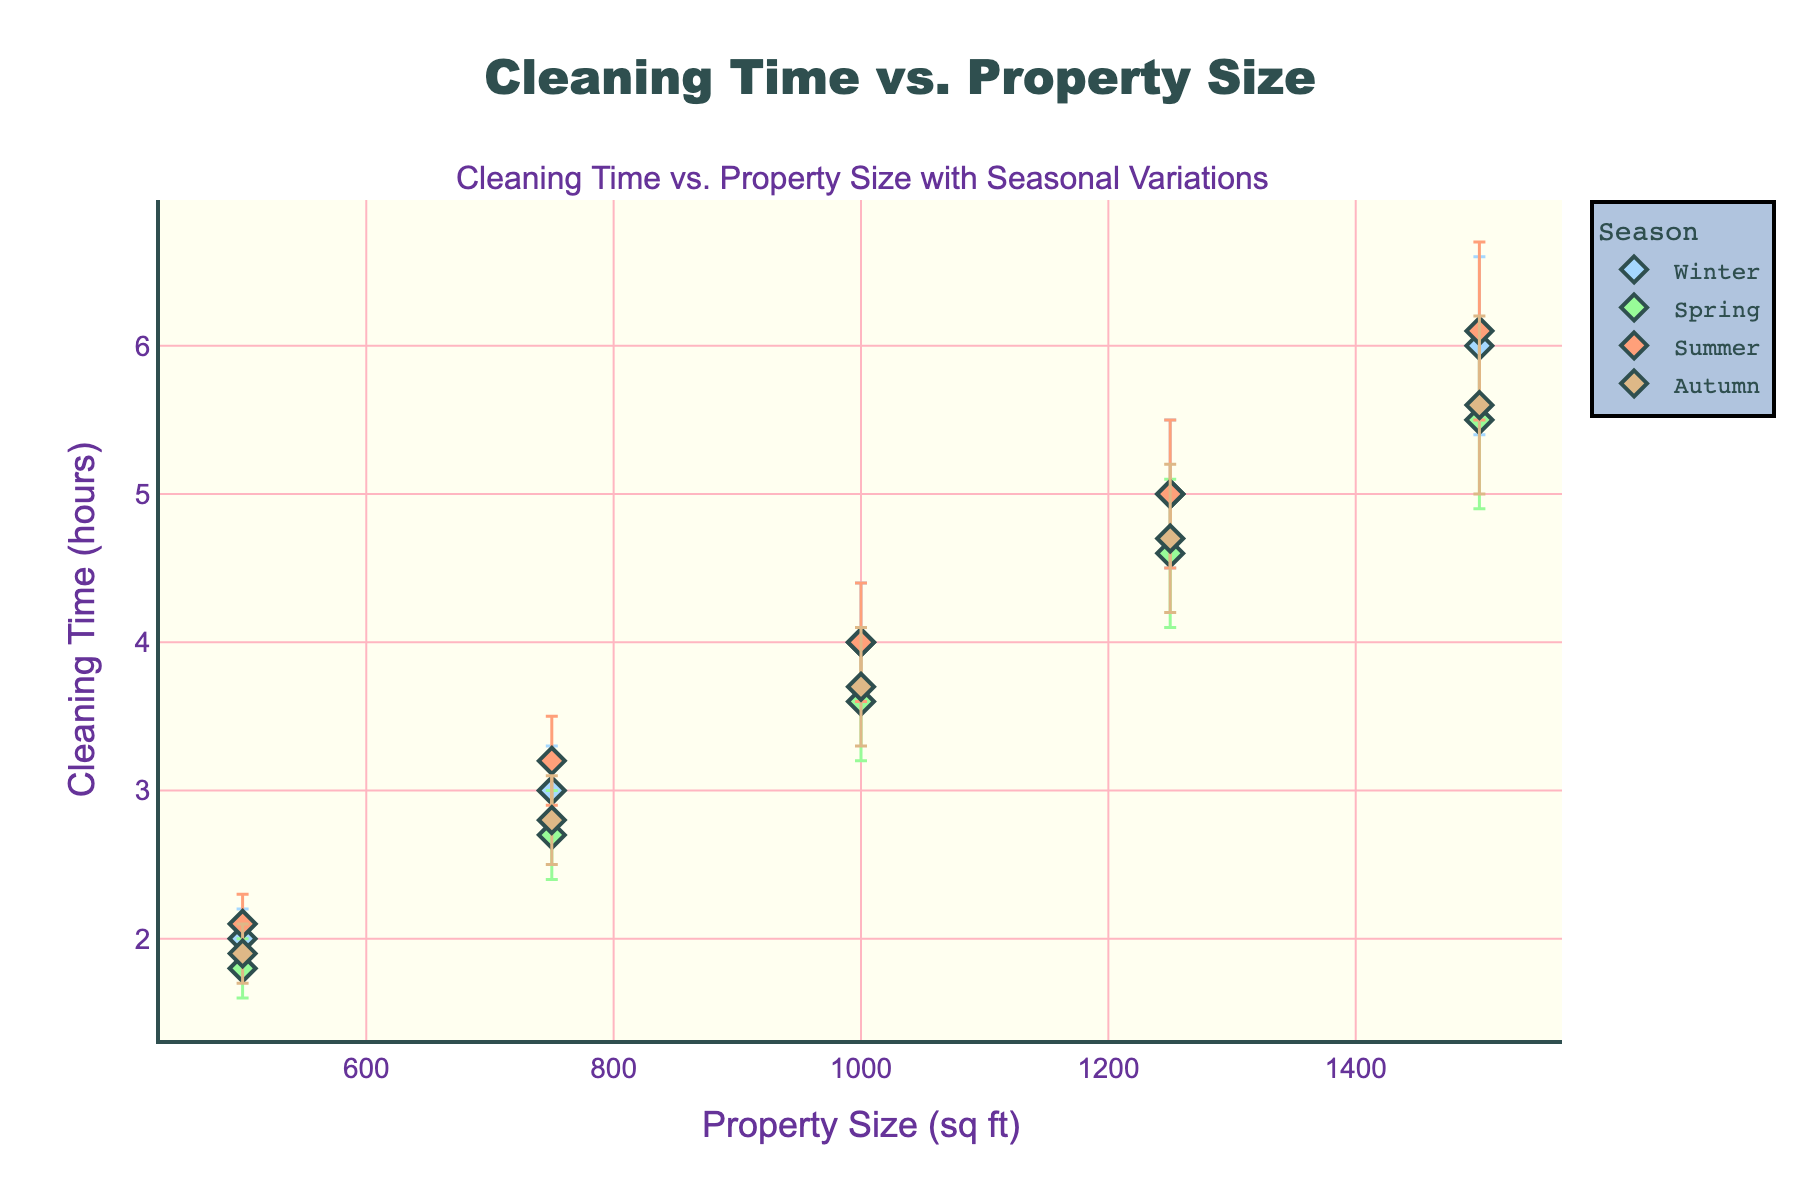What is the title of the plot? The title of the plot is mentioned at the top center. It reads "Cleaning Time vs. Property Size".
Answer: Cleaning Time vs. Property Size How does the cleaning time change as the property size increases? From the plot, we see an increasing trend. As the property size increases, cleaning time also increases for all seasons.
Answer: Increases Which season has the highest cleaning time for the largest property size (1500 sq ft)? By observing the plot, we notice that the data point for Summer at 1500 sq ft has the highest cleaning time.
Answer: Summer Which season has the lowest average cleaning time across all property sizes? To determine this, let's average the cleaning times for each season across all property sizes and compare them. Spring has the lowest average cleaning time.
Answer: Spring Are there any overlapping data points between the seasons? Overlapping data points can be identified if they share the same property size and have similar cleaning times. By closely examining, no two seasons have identical data points.
Answer: No Which season has the widest error bars on average? Error bars represent the uncertainty in the cleaning time. Observing the plot, Winter has the widest error bars on average.
Answer: Winter What property size shows the smallest variability in cleaning time across all seasons? Variability can be assessed by looking at the length of error bars, the property size 500 sq ft has the smallest variability across all seasons.
Answer: 500 sq ft How does the error bar length vary with the property size within each season? By analyzing the figure, we see that the length of error bars tends to increase with increasing property size in each season.
Answer: Increases Which season shows the largest discrepancy in cleaning time compared to others for 1000 sq ft? By comparing the points for 1000 sq ft, Summer has a larger discrepancy in cleaning time relative to the other seasons.
Answer: Summer 